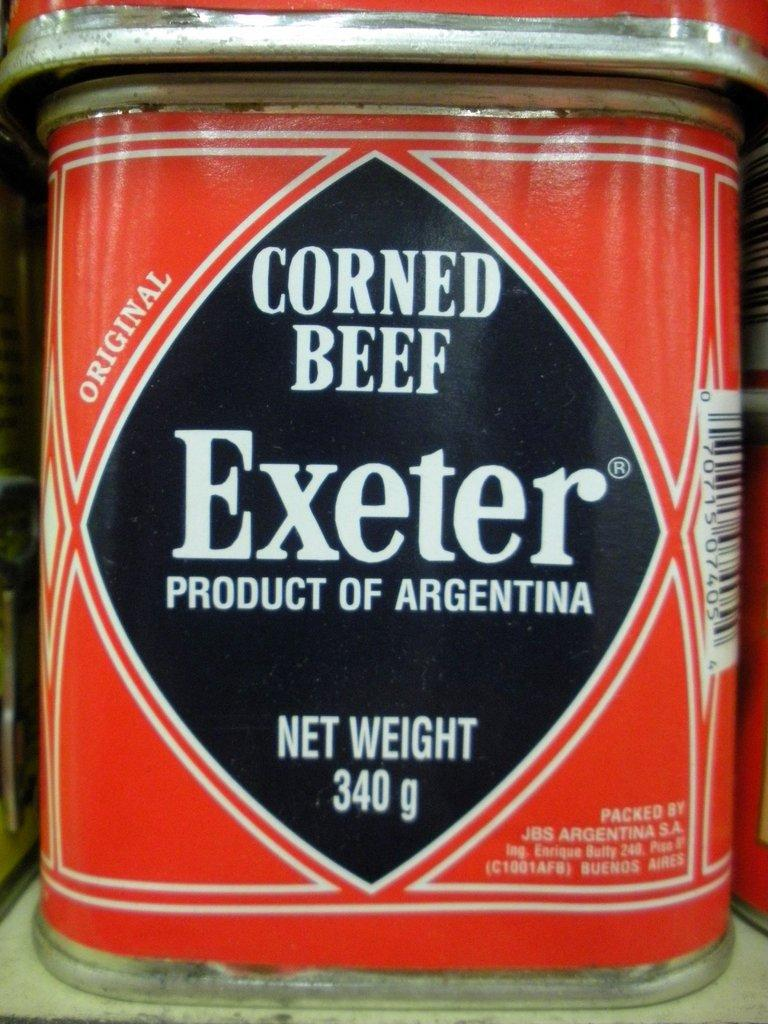<image>
Give a short and clear explanation of the subsequent image. A red can has the label Corned Beef. 